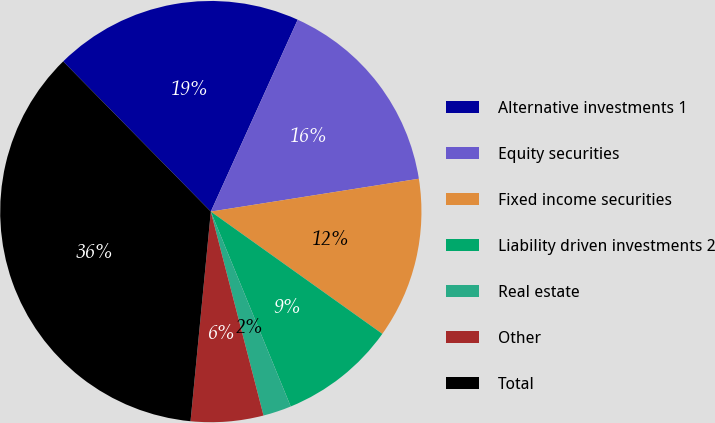<chart> <loc_0><loc_0><loc_500><loc_500><pie_chart><fcel>Alternative investments 1<fcel>Equity securities<fcel>Fixed income securities<fcel>Liability driven investments 2<fcel>Real estate<fcel>Other<fcel>Total<nl><fcel>19.13%<fcel>15.74%<fcel>12.35%<fcel>8.95%<fcel>2.17%<fcel>5.56%<fcel>36.1%<nl></chart> 